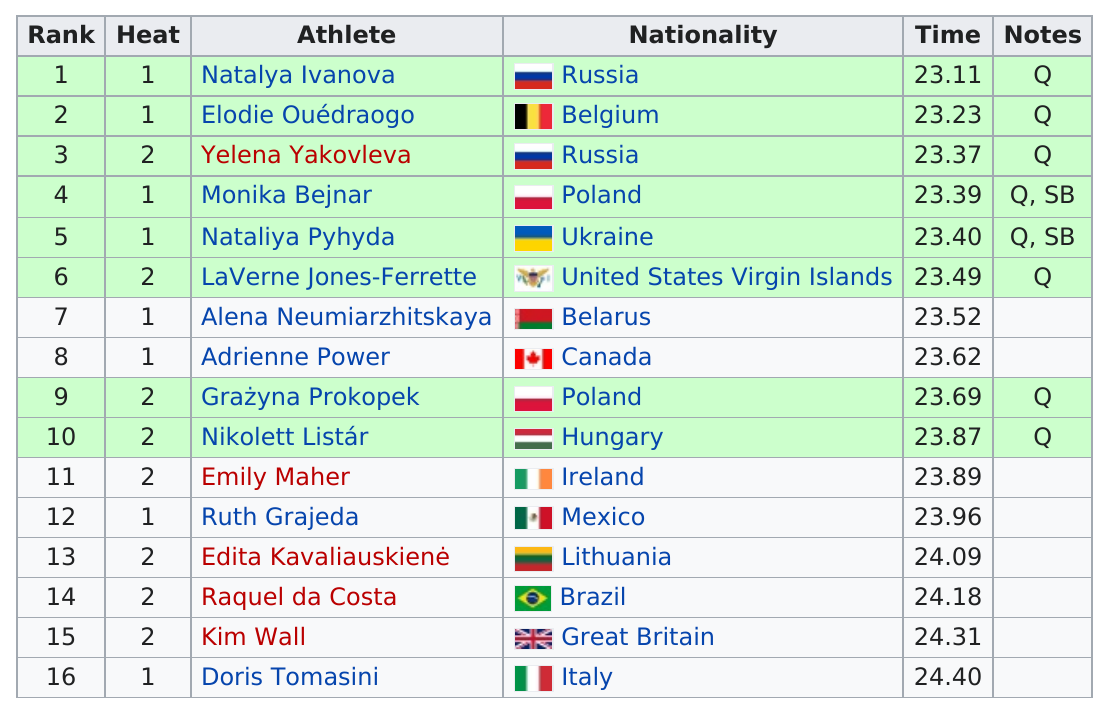Point out several critical features in this image. Raquel da Costa is the only cyclist from Brazil. Monika Bejnar is the top athlete from Poland. It is estimated that approximately two athletes from Russia are participating in the current athletic event, According to the data, out of the total number of cyclists present, approximately 2% were from Russia. The number of cyclists in the second heat was 8. 